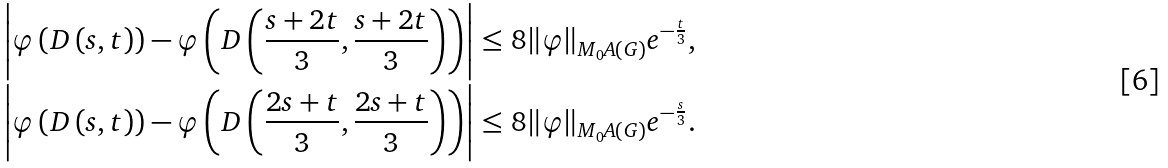Convert formula to latex. <formula><loc_0><loc_0><loc_500><loc_500>\left | \varphi \left ( D \left ( s , t \right ) \right ) - \varphi \left ( D \left ( \frac { s + 2 t } { 3 } , \frac { s + 2 t } { 3 } \right ) \right ) \right | & \leq 8 \| \varphi \| _ { M _ { 0 } A ( G ) } e ^ { - \frac { t } { 3 } } , \\ \left | \varphi \left ( D \left ( s , t \right ) \right ) - \varphi \left ( D \left ( \frac { 2 s + t } { 3 } , \frac { 2 s + t } { 3 } \right ) \right ) \right | & \leq 8 \| \varphi \| _ { M _ { 0 } A ( G ) } e ^ { - \frac { s } { 3 } } .</formula> 